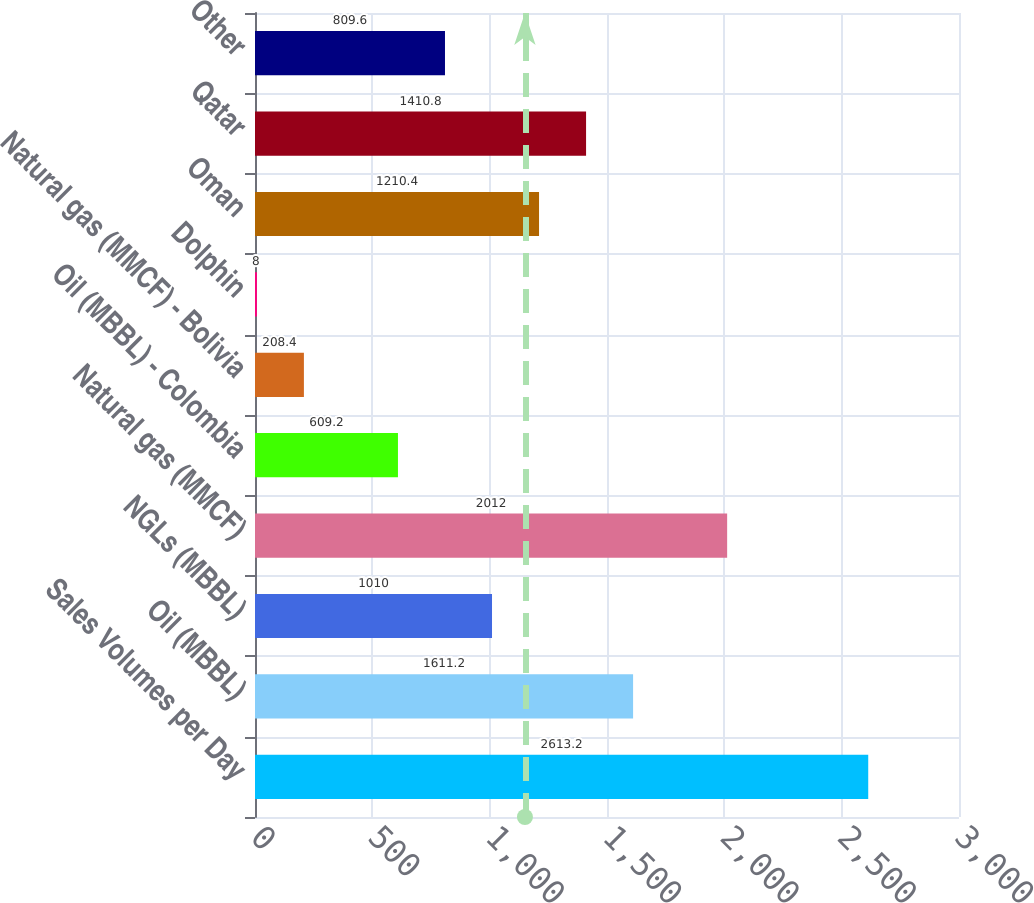<chart> <loc_0><loc_0><loc_500><loc_500><bar_chart><fcel>Sales Volumes per Day<fcel>Oil (MBBL)<fcel>NGLs (MBBL)<fcel>Natural gas (MMCF)<fcel>Oil (MBBL) - Colombia<fcel>Natural gas (MMCF) - Bolivia<fcel>Dolphin<fcel>Oman<fcel>Qatar<fcel>Other<nl><fcel>2613.2<fcel>1611.2<fcel>1010<fcel>2012<fcel>609.2<fcel>208.4<fcel>8<fcel>1210.4<fcel>1410.8<fcel>809.6<nl></chart> 